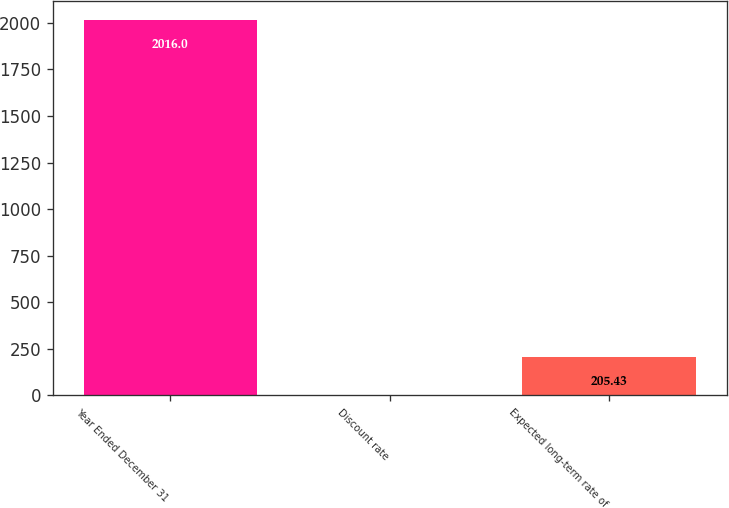<chart> <loc_0><loc_0><loc_500><loc_500><bar_chart><fcel>Year Ended December 31<fcel>Discount rate<fcel>Expected long-term rate of<nl><fcel>2016<fcel>4.25<fcel>205.43<nl></chart> 